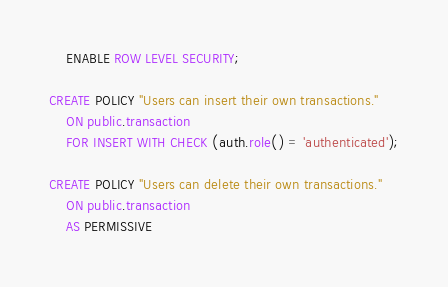Convert code to text. <code><loc_0><loc_0><loc_500><loc_500><_SQL_>    ENABLE ROW LEVEL SECURITY;

CREATE POLICY "Users can insert their own transactions."
    ON public.transaction
    FOR INSERT WITH CHECK (auth.role() = 'authenticated');

CREATE POLICY "Users can delete their own transactions."
    ON public.transaction
    AS PERMISSIVE</code> 